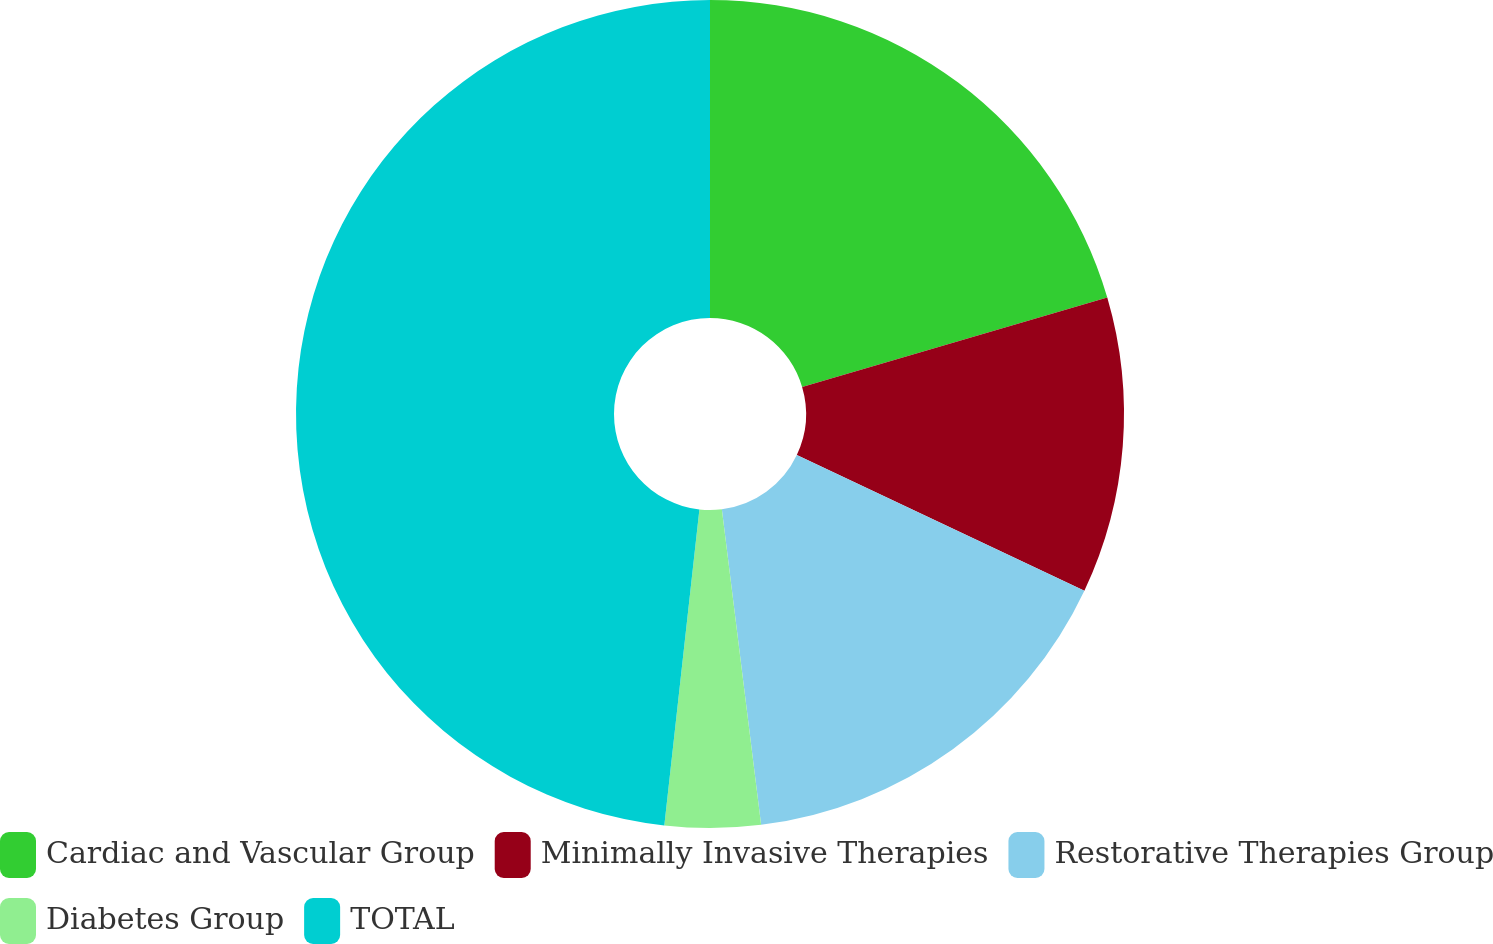Convert chart to OTSL. <chart><loc_0><loc_0><loc_500><loc_500><pie_chart><fcel>Cardiac and Vascular Group<fcel>Minimally Invasive Therapies<fcel>Restorative Therapies Group<fcel>Diabetes Group<fcel>TOTAL<nl><fcel>20.46%<fcel>11.56%<fcel>16.01%<fcel>3.73%<fcel>48.24%<nl></chart> 